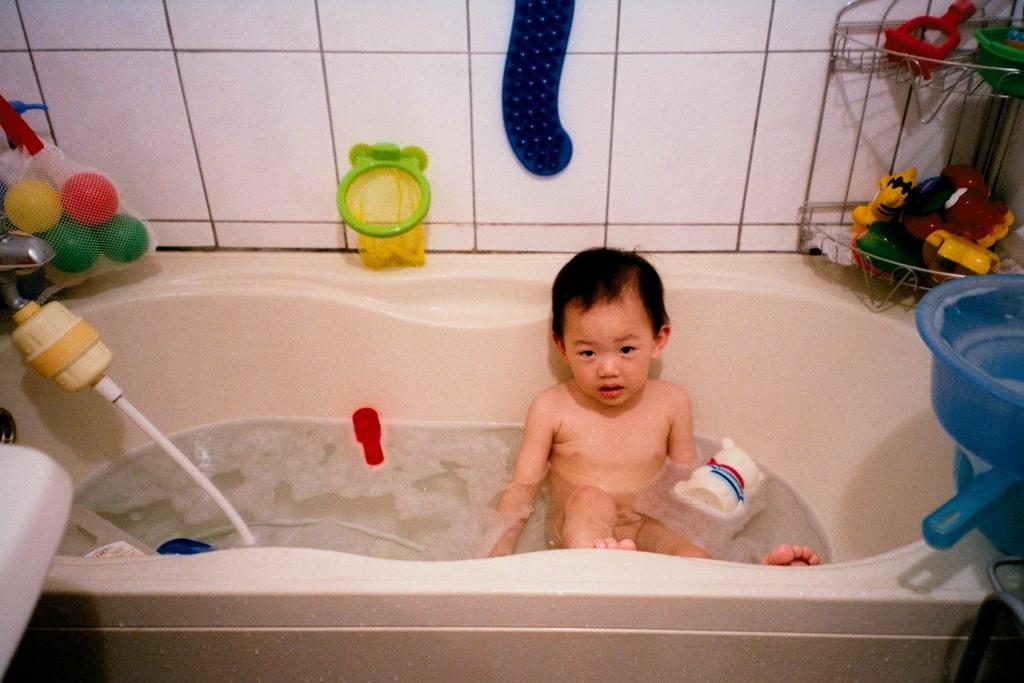What is the main subject of the image? There is a baby in a bathtub in the image. What can be seen in the water with the baby? There are balls in the water, with colors yellow, red, and green. Are there any other objects in the water? Yes, there are objects in the water. What is the surface of the bathtub made of? The bathtub has a tiled surface. Where is the vase located in the image? There is no vase present in the image. What type of food is being served in the lunchroom in the image? There is no lunchroom present in the image. 